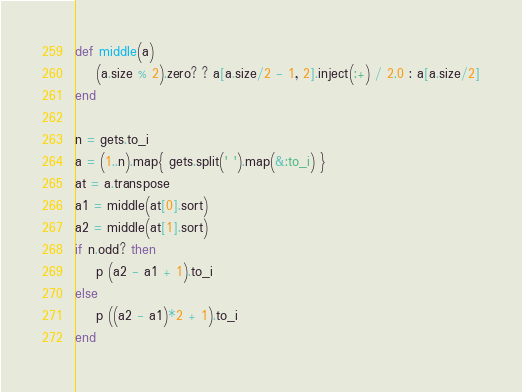<code> <loc_0><loc_0><loc_500><loc_500><_Ruby_>def middle(a)
    (a.size % 2).zero? ? a[a.size/2 - 1, 2].inject(:+) / 2.0 : a[a.size/2]
end

n = gets.to_i
a = (1..n).map{ gets.split(' ').map(&:to_i) }
at = a.transpose
a1 = middle(at[0].sort)
a2 = middle(at[1].sort)
if n.odd? then
    p (a2 - a1 + 1).to_i
else
    p ((a2 - a1)*2 + 1).to_i
end
</code> 